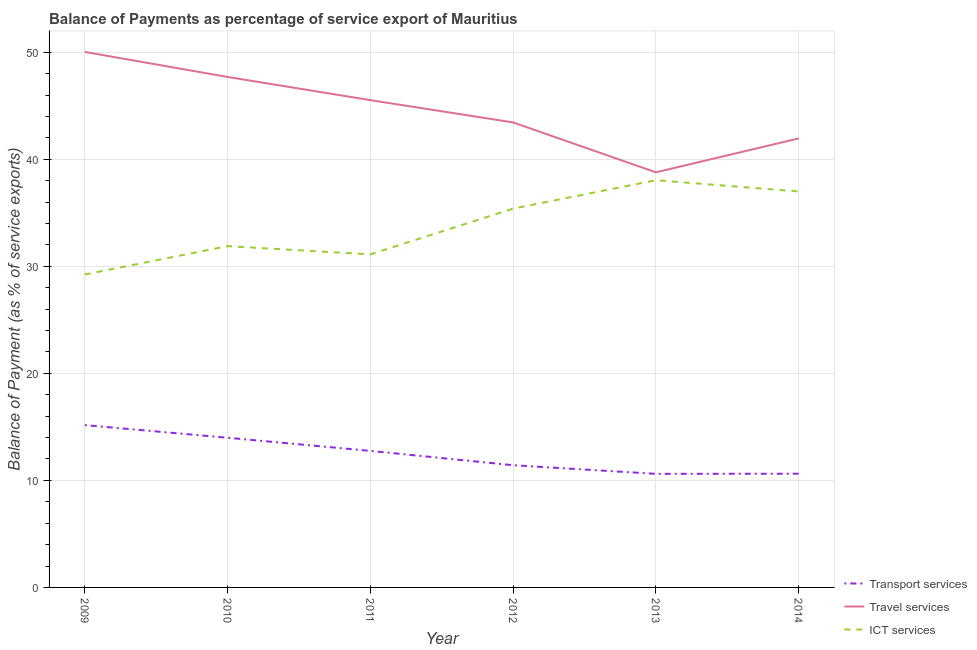Does the line corresponding to balance of payment of transport services intersect with the line corresponding to balance of payment of travel services?
Provide a short and direct response. No. What is the balance of payment of transport services in 2012?
Your answer should be compact. 11.42. Across all years, what is the maximum balance of payment of transport services?
Keep it short and to the point. 15.16. Across all years, what is the minimum balance of payment of ict services?
Your answer should be very brief. 29.24. What is the total balance of payment of transport services in the graph?
Keep it short and to the point. 74.55. What is the difference between the balance of payment of travel services in 2009 and that in 2014?
Your answer should be compact. 8.08. What is the difference between the balance of payment of ict services in 2013 and the balance of payment of transport services in 2009?
Your response must be concise. 22.88. What is the average balance of payment of ict services per year?
Your response must be concise. 33.78. In the year 2014, what is the difference between the balance of payment of ict services and balance of payment of transport services?
Ensure brevity in your answer.  26.37. In how many years, is the balance of payment of ict services greater than 22 %?
Provide a short and direct response. 6. What is the ratio of the balance of payment of ict services in 2010 to that in 2014?
Provide a short and direct response. 0.86. Is the balance of payment of ict services in 2009 less than that in 2014?
Offer a very short reply. Yes. What is the difference between the highest and the second highest balance of payment of transport services?
Make the answer very short. 1.18. What is the difference between the highest and the lowest balance of payment of ict services?
Provide a short and direct response. 8.81. Is the sum of the balance of payment of transport services in 2009 and 2014 greater than the maximum balance of payment of ict services across all years?
Give a very brief answer. No. Is it the case that in every year, the sum of the balance of payment of transport services and balance of payment of travel services is greater than the balance of payment of ict services?
Provide a succinct answer. Yes. Is the balance of payment of transport services strictly less than the balance of payment of travel services over the years?
Your answer should be very brief. Yes. How many lines are there?
Your answer should be very brief. 3. Are the values on the major ticks of Y-axis written in scientific E-notation?
Provide a succinct answer. No. Does the graph contain any zero values?
Your answer should be very brief. No. Does the graph contain grids?
Keep it short and to the point. Yes. Where does the legend appear in the graph?
Give a very brief answer. Bottom right. What is the title of the graph?
Provide a short and direct response. Balance of Payments as percentage of service export of Mauritius. What is the label or title of the Y-axis?
Offer a very short reply. Balance of Payment (as % of service exports). What is the Balance of Payment (as % of service exports) in Transport services in 2009?
Make the answer very short. 15.16. What is the Balance of Payment (as % of service exports) in Travel services in 2009?
Make the answer very short. 50.03. What is the Balance of Payment (as % of service exports) of ICT services in 2009?
Give a very brief answer. 29.24. What is the Balance of Payment (as % of service exports) in Transport services in 2010?
Offer a terse response. 13.98. What is the Balance of Payment (as % of service exports) of Travel services in 2010?
Ensure brevity in your answer.  47.69. What is the Balance of Payment (as % of service exports) of ICT services in 2010?
Offer a terse response. 31.88. What is the Balance of Payment (as % of service exports) of Transport services in 2011?
Your answer should be very brief. 12.76. What is the Balance of Payment (as % of service exports) of Travel services in 2011?
Keep it short and to the point. 45.52. What is the Balance of Payment (as % of service exports) in ICT services in 2011?
Your response must be concise. 31.12. What is the Balance of Payment (as % of service exports) in Transport services in 2012?
Make the answer very short. 11.42. What is the Balance of Payment (as % of service exports) of Travel services in 2012?
Your answer should be compact. 43.44. What is the Balance of Payment (as % of service exports) in ICT services in 2012?
Keep it short and to the point. 35.39. What is the Balance of Payment (as % of service exports) in Transport services in 2013?
Give a very brief answer. 10.61. What is the Balance of Payment (as % of service exports) of Travel services in 2013?
Make the answer very short. 38.78. What is the Balance of Payment (as % of service exports) of ICT services in 2013?
Give a very brief answer. 38.04. What is the Balance of Payment (as % of service exports) in Transport services in 2014?
Make the answer very short. 10.62. What is the Balance of Payment (as % of service exports) in Travel services in 2014?
Make the answer very short. 41.95. What is the Balance of Payment (as % of service exports) of ICT services in 2014?
Ensure brevity in your answer.  36.99. Across all years, what is the maximum Balance of Payment (as % of service exports) of Transport services?
Your response must be concise. 15.16. Across all years, what is the maximum Balance of Payment (as % of service exports) in Travel services?
Offer a very short reply. 50.03. Across all years, what is the maximum Balance of Payment (as % of service exports) in ICT services?
Your response must be concise. 38.04. Across all years, what is the minimum Balance of Payment (as % of service exports) of Transport services?
Keep it short and to the point. 10.61. Across all years, what is the minimum Balance of Payment (as % of service exports) of Travel services?
Provide a short and direct response. 38.78. Across all years, what is the minimum Balance of Payment (as % of service exports) of ICT services?
Make the answer very short. 29.24. What is the total Balance of Payment (as % of service exports) in Transport services in the graph?
Keep it short and to the point. 74.55. What is the total Balance of Payment (as % of service exports) of Travel services in the graph?
Keep it short and to the point. 267.41. What is the total Balance of Payment (as % of service exports) of ICT services in the graph?
Your answer should be compact. 202.66. What is the difference between the Balance of Payment (as % of service exports) of Transport services in 2009 and that in 2010?
Provide a succinct answer. 1.18. What is the difference between the Balance of Payment (as % of service exports) in Travel services in 2009 and that in 2010?
Provide a short and direct response. 2.34. What is the difference between the Balance of Payment (as % of service exports) in ICT services in 2009 and that in 2010?
Your answer should be very brief. -2.65. What is the difference between the Balance of Payment (as % of service exports) of Transport services in 2009 and that in 2011?
Your response must be concise. 2.41. What is the difference between the Balance of Payment (as % of service exports) of Travel services in 2009 and that in 2011?
Your response must be concise. 4.5. What is the difference between the Balance of Payment (as % of service exports) in ICT services in 2009 and that in 2011?
Your response must be concise. -1.88. What is the difference between the Balance of Payment (as % of service exports) of Transport services in 2009 and that in 2012?
Your answer should be very brief. 3.75. What is the difference between the Balance of Payment (as % of service exports) of Travel services in 2009 and that in 2012?
Your answer should be compact. 6.59. What is the difference between the Balance of Payment (as % of service exports) in ICT services in 2009 and that in 2012?
Give a very brief answer. -6.15. What is the difference between the Balance of Payment (as % of service exports) of Transport services in 2009 and that in 2013?
Keep it short and to the point. 4.55. What is the difference between the Balance of Payment (as % of service exports) of Travel services in 2009 and that in 2013?
Ensure brevity in your answer.  11.25. What is the difference between the Balance of Payment (as % of service exports) of ICT services in 2009 and that in 2013?
Ensure brevity in your answer.  -8.81. What is the difference between the Balance of Payment (as % of service exports) of Transport services in 2009 and that in 2014?
Your response must be concise. 4.54. What is the difference between the Balance of Payment (as % of service exports) in Travel services in 2009 and that in 2014?
Provide a succinct answer. 8.08. What is the difference between the Balance of Payment (as % of service exports) of ICT services in 2009 and that in 2014?
Make the answer very short. -7.76. What is the difference between the Balance of Payment (as % of service exports) in Transport services in 2010 and that in 2011?
Provide a short and direct response. 1.23. What is the difference between the Balance of Payment (as % of service exports) in Travel services in 2010 and that in 2011?
Ensure brevity in your answer.  2.17. What is the difference between the Balance of Payment (as % of service exports) of ICT services in 2010 and that in 2011?
Give a very brief answer. 0.77. What is the difference between the Balance of Payment (as % of service exports) of Transport services in 2010 and that in 2012?
Give a very brief answer. 2.57. What is the difference between the Balance of Payment (as % of service exports) of Travel services in 2010 and that in 2012?
Keep it short and to the point. 4.25. What is the difference between the Balance of Payment (as % of service exports) in ICT services in 2010 and that in 2012?
Provide a succinct answer. -3.5. What is the difference between the Balance of Payment (as % of service exports) of Transport services in 2010 and that in 2013?
Make the answer very short. 3.37. What is the difference between the Balance of Payment (as % of service exports) in Travel services in 2010 and that in 2013?
Offer a very short reply. 8.91. What is the difference between the Balance of Payment (as % of service exports) of ICT services in 2010 and that in 2013?
Offer a terse response. -6.16. What is the difference between the Balance of Payment (as % of service exports) of Transport services in 2010 and that in 2014?
Make the answer very short. 3.36. What is the difference between the Balance of Payment (as % of service exports) in Travel services in 2010 and that in 2014?
Offer a very short reply. 5.74. What is the difference between the Balance of Payment (as % of service exports) of ICT services in 2010 and that in 2014?
Provide a short and direct response. -5.11. What is the difference between the Balance of Payment (as % of service exports) of Transport services in 2011 and that in 2012?
Your response must be concise. 1.34. What is the difference between the Balance of Payment (as % of service exports) in Travel services in 2011 and that in 2012?
Keep it short and to the point. 2.08. What is the difference between the Balance of Payment (as % of service exports) of ICT services in 2011 and that in 2012?
Your answer should be compact. -4.27. What is the difference between the Balance of Payment (as % of service exports) of Transport services in 2011 and that in 2013?
Give a very brief answer. 2.15. What is the difference between the Balance of Payment (as % of service exports) in Travel services in 2011 and that in 2013?
Your answer should be very brief. 6.74. What is the difference between the Balance of Payment (as % of service exports) of ICT services in 2011 and that in 2013?
Provide a succinct answer. -6.93. What is the difference between the Balance of Payment (as % of service exports) of Transport services in 2011 and that in 2014?
Provide a succinct answer. 2.13. What is the difference between the Balance of Payment (as % of service exports) in Travel services in 2011 and that in 2014?
Your answer should be compact. 3.58. What is the difference between the Balance of Payment (as % of service exports) of ICT services in 2011 and that in 2014?
Provide a succinct answer. -5.88. What is the difference between the Balance of Payment (as % of service exports) of Transport services in 2012 and that in 2013?
Ensure brevity in your answer.  0.81. What is the difference between the Balance of Payment (as % of service exports) in Travel services in 2012 and that in 2013?
Your answer should be very brief. 4.66. What is the difference between the Balance of Payment (as % of service exports) of ICT services in 2012 and that in 2013?
Your response must be concise. -2.65. What is the difference between the Balance of Payment (as % of service exports) of Transport services in 2012 and that in 2014?
Offer a terse response. 0.79. What is the difference between the Balance of Payment (as % of service exports) of Travel services in 2012 and that in 2014?
Provide a succinct answer. 1.5. What is the difference between the Balance of Payment (as % of service exports) in ICT services in 2012 and that in 2014?
Give a very brief answer. -1.6. What is the difference between the Balance of Payment (as % of service exports) of Transport services in 2013 and that in 2014?
Give a very brief answer. -0.01. What is the difference between the Balance of Payment (as % of service exports) of Travel services in 2013 and that in 2014?
Offer a very short reply. -3.17. What is the difference between the Balance of Payment (as % of service exports) of ICT services in 2013 and that in 2014?
Your answer should be very brief. 1.05. What is the difference between the Balance of Payment (as % of service exports) in Transport services in 2009 and the Balance of Payment (as % of service exports) in Travel services in 2010?
Provide a succinct answer. -32.52. What is the difference between the Balance of Payment (as % of service exports) in Transport services in 2009 and the Balance of Payment (as % of service exports) in ICT services in 2010?
Your response must be concise. -16.72. What is the difference between the Balance of Payment (as % of service exports) in Travel services in 2009 and the Balance of Payment (as % of service exports) in ICT services in 2010?
Offer a terse response. 18.14. What is the difference between the Balance of Payment (as % of service exports) in Transport services in 2009 and the Balance of Payment (as % of service exports) in Travel services in 2011?
Your answer should be compact. -30.36. What is the difference between the Balance of Payment (as % of service exports) in Transport services in 2009 and the Balance of Payment (as % of service exports) in ICT services in 2011?
Offer a very short reply. -15.95. What is the difference between the Balance of Payment (as % of service exports) in Travel services in 2009 and the Balance of Payment (as % of service exports) in ICT services in 2011?
Offer a terse response. 18.91. What is the difference between the Balance of Payment (as % of service exports) in Transport services in 2009 and the Balance of Payment (as % of service exports) in Travel services in 2012?
Give a very brief answer. -28.28. What is the difference between the Balance of Payment (as % of service exports) of Transport services in 2009 and the Balance of Payment (as % of service exports) of ICT services in 2012?
Offer a terse response. -20.22. What is the difference between the Balance of Payment (as % of service exports) of Travel services in 2009 and the Balance of Payment (as % of service exports) of ICT services in 2012?
Provide a succinct answer. 14.64. What is the difference between the Balance of Payment (as % of service exports) in Transport services in 2009 and the Balance of Payment (as % of service exports) in Travel services in 2013?
Your response must be concise. -23.61. What is the difference between the Balance of Payment (as % of service exports) of Transport services in 2009 and the Balance of Payment (as % of service exports) of ICT services in 2013?
Ensure brevity in your answer.  -22.88. What is the difference between the Balance of Payment (as % of service exports) of Travel services in 2009 and the Balance of Payment (as % of service exports) of ICT services in 2013?
Offer a terse response. 11.99. What is the difference between the Balance of Payment (as % of service exports) in Transport services in 2009 and the Balance of Payment (as % of service exports) in Travel services in 2014?
Your answer should be very brief. -26.78. What is the difference between the Balance of Payment (as % of service exports) of Transport services in 2009 and the Balance of Payment (as % of service exports) of ICT services in 2014?
Give a very brief answer. -21.83. What is the difference between the Balance of Payment (as % of service exports) in Travel services in 2009 and the Balance of Payment (as % of service exports) in ICT services in 2014?
Provide a short and direct response. 13.03. What is the difference between the Balance of Payment (as % of service exports) in Transport services in 2010 and the Balance of Payment (as % of service exports) in Travel services in 2011?
Ensure brevity in your answer.  -31.54. What is the difference between the Balance of Payment (as % of service exports) in Transport services in 2010 and the Balance of Payment (as % of service exports) in ICT services in 2011?
Provide a short and direct response. -17.13. What is the difference between the Balance of Payment (as % of service exports) of Travel services in 2010 and the Balance of Payment (as % of service exports) of ICT services in 2011?
Offer a terse response. 16.57. What is the difference between the Balance of Payment (as % of service exports) of Transport services in 2010 and the Balance of Payment (as % of service exports) of Travel services in 2012?
Offer a very short reply. -29.46. What is the difference between the Balance of Payment (as % of service exports) in Transport services in 2010 and the Balance of Payment (as % of service exports) in ICT services in 2012?
Your answer should be compact. -21.41. What is the difference between the Balance of Payment (as % of service exports) in Travel services in 2010 and the Balance of Payment (as % of service exports) in ICT services in 2012?
Provide a succinct answer. 12.3. What is the difference between the Balance of Payment (as % of service exports) in Transport services in 2010 and the Balance of Payment (as % of service exports) in Travel services in 2013?
Ensure brevity in your answer.  -24.8. What is the difference between the Balance of Payment (as % of service exports) in Transport services in 2010 and the Balance of Payment (as % of service exports) in ICT services in 2013?
Your response must be concise. -24.06. What is the difference between the Balance of Payment (as % of service exports) in Travel services in 2010 and the Balance of Payment (as % of service exports) in ICT services in 2013?
Keep it short and to the point. 9.65. What is the difference between the Balance of Payment (as % of service exports) in Transport services in 2010 and the Balance of Payment (as % of service exports) in Travel services in 2014?
Your response must be concise. -27.96. What is the difference between the Balance of Payment (as % of service exports) of Transport services in 2010 and the Balance of Payment (as % of service exports) of ICT services in 2014?
Keep it short and to the point. -23.01. What is the difference between the Balance of Payment (as % of service exports) of Travel services in 2010 and the Balance of Payment (as % of service exports) of ICT services in 2014?
Keep it short and to the point. 10.7. What is the difference between the Balance of Payment (as % of service exports) in Transport services in 2011 and the Balance of Payment (as % of service exports) in Travel services in 2012?
Provide a short and direct response. -30.69. What is the difference between the Balance of Payment (as % of service exports) of Transport services in 2011 and the Balance of Payment (as % of service exports) of ICT services in 2012?
Keep it short and to the point. -22.63. What is the difference between the Balance of Payment (as % of service exports) of Travel services in 2011 and the Balance of Payment (as % of service exports) of ICT services in 2012?
Provide a short and direct response. 10.13. What is the difference between the Balance of Payment (as % of service exports) in Transport services in 2011 and the Balance of Payment (as % of service exports) in Travel services in 2013?
Your answer should be very brief. -26.02. What is the difference between the Balance of Payment (as % of service exports) of Transport services in 2011 and the Balance of Payment (as % of service exports) of ICT services in 2013?
Give a very brief answer. -25.29. What is the difference between the Balance of Payment (as % of service exports) of Travel services in 2011 and the Balance of Payment (as % of service exports) of ICT services in 2013?
Provide a short and direct response. 7.48. What is the difference between the Balance of Payment (as % of service exports) of Transport services in 2011 and the Balance of Payment (as % of service exports) of Travel services in 2014?
Provide a short and direct response. -29.19. What is the difference between the Balance of Payment (as % of service exports) in Transport services in 2011 and the Balance of Payment (as % of service exports) in ICT services in 2014?
Give a very brief answer. -24.24. What is the difference between the Balance of Payment (as % of service exports) in Travel services in 2011 and the Balance of Payment (as % of service exports) in ICT services in 2014?
Your answer should be very brief. 8.53. What is the difference between the Balance of Payment (as % of service exports) of Transport services in 2012 and the Balance of Payment (as % of service exports) of Travel services in 2013?
Give a very brief answer. -27.36. What is the difference between the Balance of Payment (as % of service exports) in Transport services in 2012 and the Balance of Payment (as % of service exports) in ICT services in 2013?
Keep it short and to the point. -26.63. What is the difference between the Balance of Payment (as % of service exports) in Travel services in 2012 and the Balance of Payment (as % of service exports) in ICT services in 2013?
Keep it short and to the point. 5.4. What is the difference between the Balance of Payment (as % of service exports) in Transport services in 2012 and the Balance of Payment (as % of service exports) in Travel services in 2014?
Your answer should be very brief. -30.53. What is the difference between the Balance of Payment (as % of service exports) of Transport services in 2012 and the Balance of Payment (as % of service exports) of ICT services in 2014?
Offer a terse response. -25.58. What is the difference between the Balance of Payment (as % of service exports) of Travel services in 2012 and the Balance of Payment (as % of service exports) of ICT services in 2014?
Provide a short and direct response. 6.45. What is the difference between the Balance of Payment (as % of service exports) in Transport services in 2013 and the Balance of Payment (as % of service exports) in Travel services in 2014?
Offer a very short reply. -31.34. What is the difference between the Balance of Payment (as % of service exports) of Transport services in 2013 and the Balance of Payment (as % of service exports) of ICT services in 2014?
Provide a short and direct response. -26.38. What is the difference between the Balance of Payment (as % of service exports) in Travel services in 2013 and the Balance of Payment (as % of service exports) in ICT services in 2014?
Provide a short and direct response. 1.79. What is the average Balance of Payment (as % of service exports) in Transport services per year?
Keep it short and to the point. 12.43. What is the average Balance of Payment (as % of service exports) in Travel services per year?
Ensure brevity in your answer.  44.57. What is the average Balance of Payment (as % of service exports) of ICT services per year?
Provide a short and direct response. 33.78. In the year 2009, what is the difference between the Balance of Payment (as % of service exports) in Transport services and Balance of Payment (as % of service exports) in Travel services?
Keep it short and to the point. -34.86. In the year 2009, what is the difference between the Balance of Payment (as % of service exports) of Transport services and Balance of Payment (as % of service exports) of ICT services?
Provide a succinct answer. -14.07. In the year 2009, what is the difference between the Balance of Payment (as % of service exports) of Travel services and Balance of Payment (as % of service exports) of ICT services?
Make the answer very short. 20.79. In the year 2010, what is the difference between the Balance of Payment (as % of service exports) of Transport services and Balance of Payment (as % of service exports) of Travel services?
Offer a very short reply. -33.71. In the year 2010, what is the difference between the Balance of Payment (as % of service exports) in Transport services and Balance of Payment (as % of service exports) in ICT services?
Keep it short and to the point. -17.9. In the year 2010, what is the difference between the Balance of Payment (as % of service exports) in Travel services and Balance of Payment (as % of service exports) in ICT services?
Offer a terse response. 15.8. In the year 2011, what is the difference between the Balance of Payment (as % of service exports) of Transport services and Balance of Payment (as % of service exports) of Travel services?
Your answer should be very brief. -32.77. In the year 2011, what is the difference between the Balance of Payment (as % of service exports) of Transport services and Balance of Payment (as % of service exports) of ICT services?
Offer a terse response. -18.36. In the year 2011, what is the difference between the Balance of Payment (as % of service exports) in Travel services and Balance of Payment (as % of service exports) in ICT services?
Offer a terse response. 14.41. In the year 2012, what is the difference between the Balance of Payment (as % of service exports) in Transport services and Balance of Payment (as % of service exports) in Travel services?
Your answer should be compact. -32.02. In the year 2012, what is the difference between the Balance of Payment (as % of service exports) in Transport services and Balance of Payment (as % of service exports) in ICT services?
Ensure brevity in your answer.  -23.97. In the year 2012, what is the difference between the Balance of Payment (as % of service exports) of Travel services and Balance of Payment (as % of service exports) of ICT services?
Your response must be concise. 8.05. In the year 2013, what is the difference between the Balance of Payment (as % of service exports) of Transport services and Balance of Payment (as % of service exports) of Travel services?
Offer a terse response. -28.17. In the year 2013, what is the difference between the Balance of Payment (as % of service exports) in Transport services and Balance of Payment (as % of service exports) in ICT services?
Make the answer very short. -27.43. In the year 2013, what is the difference between the Balance of Payment (as % of service exports) in Travel services and Balance of Payment (as % of service exports) in ICT services?
Give a very brief answer. 0.74. In the year 2014, what is the difference between the Balance of Payment (as % of service exports) in Transport services and Balance of Payment (as % of service exports) in Travel services?
Keep it short and to the point. -31.32. In the year 2014, what is the difference between the Balance of Payment (as % of service exports) of Transport services and Balance of Payment (as % of service exports) of ICT services?
Offer a terse response. -26.37. In the year 2014, what is the difference between the Balance of Payment (as % of service exports) in Travel services and Balance of Payment (as % of service exports) in ICT services?
Provide a succinct answer. 4.95. What is the ratio of the Balance of Payment (as % of service exports) of Transport services in 2009 to that in 2010?
Ensure brevity in your answer.  1.08. What is the ratio of the Balance of Payment (as % of service exports) in Travel services in 2009 to that in 2010?
Ensure brevity in your answer.  1.05. What is the ratio of the Balance of Payment (as % of service exports) in ICT services in 2009 to that in 2010?
Offer a very short reply. 0.92. What is the ratio of the Balance of Payment (as % of service exports) of Transport services in 2009 to that in 2011?
Provide a short and direct response. 1.19. What is the ratio of the Balance of Payment (as % of service exports) in Travel services in 2009 to that in 2011?
Your answer should be compact. 1.1. What is the ratio of the Balance of Payment (as % of service exports) of ICT services in 2009 to that in 2011?
Your answer should be very brief. 0.94. What is the ratio of the Balance of Payment (as % of service exports) in Transport services in 2009 to that in 2012?
Give a very brief answer. 1.33. What is the ratio of the Balance of Payment (as % of service exports) of Travel services in 2009 to that in 2012?
Offer a terse response. 1.15. What is the ratio of the Balance of Payment (as % of service exports) in ICT services in 2009 to that in 2012?
Make the answer very short. 0.83. What is the ratio of the Balance of Payment (as % of service exports) of Transport services in 2009 to that in 2013?
Keep it short and to the point. 1.43. What is the ratio of the Balance of Payment (as % of service exports) of Travel services in 2009 to that in 2013?
Your response must be concise. 1.29. What is the ratio of the Balance of Payment (as % of service exports) in ICT services in 2009 to that in 2013?
Your response must be concise. 0.77. What is the ratio of the Balance of Payment (as % of service exports) in Transport services in 2009 to that in 2014?
Provide a short and direct response. 1.43. What is the ratio of the Balance of Payment (as % of service exports) in Travel services in 2009 to that in 2014?
Your answer should be very brief. 1.19. What is the ratio of the Balance of Payment (as % of service exports) of ICT services in 2009 to that in 2014?
Make the answer very short. 0.79. What is the ratio of the Balance of Payment (as % of service exports) of Transport services in 2010 to that in 2011?
Ensure brevity in your answer.  1.1. What is the ratio of the Balance of Payment (as % of service exports) of Travel services in 2010 to that in 2011?
Keep it short and to the point. 1.05. What is the ratio of the Balance of Payment (as % of service exports) of ICT services in 2010 to that in 2011?
Make the answer very short. 1.02. What is the ratio of the Balance of Payment (as % of service exports) of Transport services in 2010 to that in 2012?
Your answer should be compact. 1.22. What is the ratio of the Balance of Payment (as % of service exports) of Travel services in 2010 to that in 2012?
Make the answer very short. 1.1. What is the ratio of the Balance of Payment (as % of service exports) of ICT services in 2010 to that in 2012?
Offer a terse response. 0.9. What is the ratio of the Balance of Payment (as % of service exports) of Transport services in 2010 to that in 2013?
Your response must be concise. 1.32. What is the ratio of the Balance of Payment (as % of service exports) in Travel services in 2010 to that in 2013?
Your response must be concise. 1.23. What is the ratio of the Balance of Payment (as % of service exports) of ICT services in 2010 to that in 2013?
Your answer should be very brief. 0.84. What is the ratio of the Balance of Payment (as % of service exports) of Transport services in 2010 to that in 2014?
Your answer should be very brief. 1.32. What is the ratio of the Balance of Payment (as % of service exports) in Travel services in 2010 to that in 2014?
Offer a terse response. 1.14. What is the ratio of the Balance of Payment (as % of service exports) of ICT services in 2010 to that in 2014?
Ensure brevity in your answer.  0.86. What is the ratio of the Balance of Payment (as % of service exports) in Transport services in 2011 to that in 2012?
Your response must be concise. 1.12. What is the ratio of the Balance of Payment (as % of service exports) in Travel services in 2011 to that in 2012?
Ensure brevity in your answer.  1.05. What is the ratio of the Balance of Payment (as % of service exports) of ICT services in 2011 to that in 2012?
Provide a short and direct response. 0.88. What is the ratio of the Balance of Payment (as % of service exports) of Transport services in 2011 to that in 2013?
Offer a terse response. 1.2. What is the ratio of the Balance of Payment (as % of service exports) of Travel services in 2011 to that in 2013?
Keep it short and to the point. 1.17. What is the ratio of the Balance of Payment (as % of service exports) in ICT services in 2011 to that in 2013?
Keep it short and to the point. 0.82. What is the ratio of the Balance of Payment (as % of service exports) in Transport services in 2011 to that in 2014?
Your answer should be very brief. 1.2. What is the ratio of the Balance of Payment (as % of service exports) of Travel services in 2011 to that in 2014?
Your response must be concise. 1.09. What is the ratio of the Balance of Payment (as % of service exports) of ICT services in 2011 to that in 2014?
Offer a very short reply. 0.84. What is the ratio of the Balance of Payment (as % of service exports) of Transport services in 2012 to that in 2013?
Provide a succinct answer. 1.08. What is the ratio of the Balance of Payment (as % of service exports) in Travel services in 2012 to that in 2013?
Your answer should be very brief. 1.12. What is the ratio of the Balance of Payment (as % of service exports) of ICT services in 2012 to that in 2013?
Ensure brevity in your answer.  0.93. What is the ratio of the Balance of Payment (as % of service exports) of Transport services in 2012 to that in 2014?
Ensure brevity in your answer.  1.07. What is the ratio of the Balance of Payment (as % of service exports) of Travel services in 2012 to that in 2014?
Ensure brevity in your answer.  1.04. What is the ratio of the Balance of Payment (as % of service exports) of ICT services in 2012 to that in 2014?
Your answer should be compact. 0.96. What is the ratio of the Balance of Payment (as % of service exports) of Transport services in 2013 to that in 2014?
Keep it short and to the point. 1. What is the ratio of the Balance of Payment (as % of service exports) of Travel services in 2013 to that in 2014?
Ensure brevity in your answer.  0.92. What is the ratio of the Balance of Payment (as % of service exports) of ICT services in 2013 to that in 2014?
Make the answer very short. 1.03. What is the difference between the highest and the second highest Balance of Payment (as % of service exports) of Transport services?
Your answer should be compact. 1.18. What is the difference between the highest and the second highest Balance of Payment (as % of service exports) of Travel services?
Provide a succinct answer. 2.34. What is the difference between the highest and the second highest Balance of Payment (as % of service exports) of ICT services?
Provide a short and direct response. 1.05. What is the difference between the highest and the lowest Balance of Payment (as % of service exports) of Transport services?
Give a very brief answer. 4.55. What is the difference between the highest and the lowest Balance of Payment (as % of service exports) in Travel services?
Keep it short and to the point. 11.25. What is the difference between the highest and the lowest Balance of Payment (as % of service exports) of ICT services?
Your answer should be very brief. 8.81. 